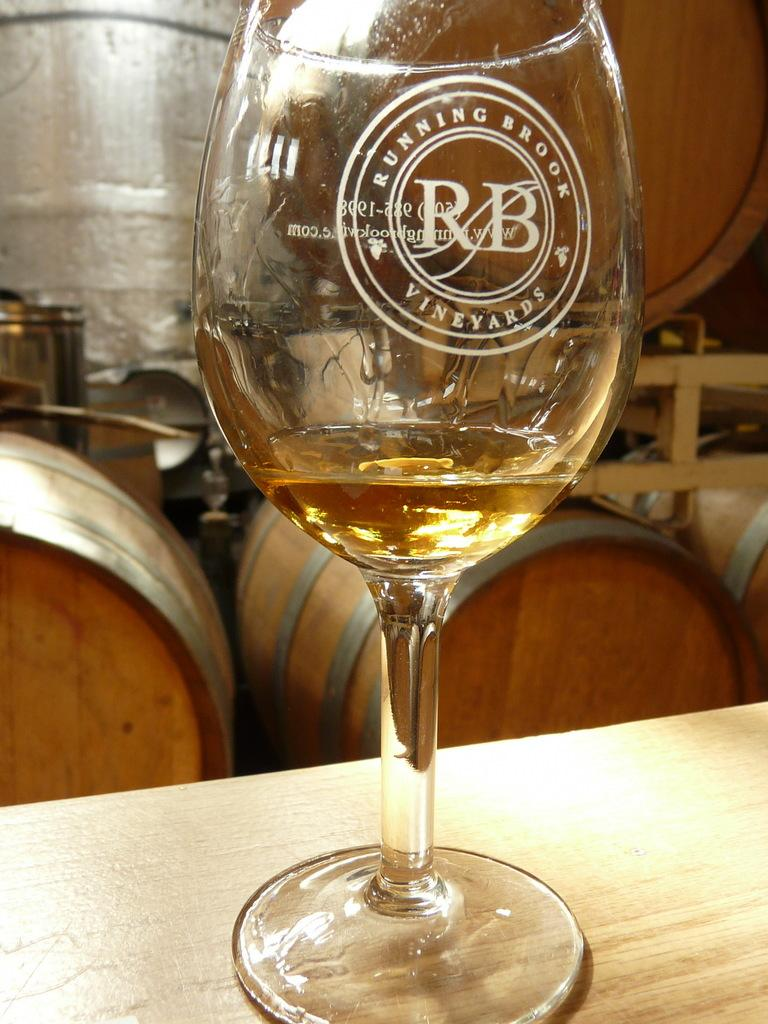What is on the table in the image? There is a glass with liquid on the table. What else can be seen on the table? There are containers on the table. What type of quilt is draped over the glass in the image? There is no quilt present in the image; it only features a glass with liquid and containers on the table. 